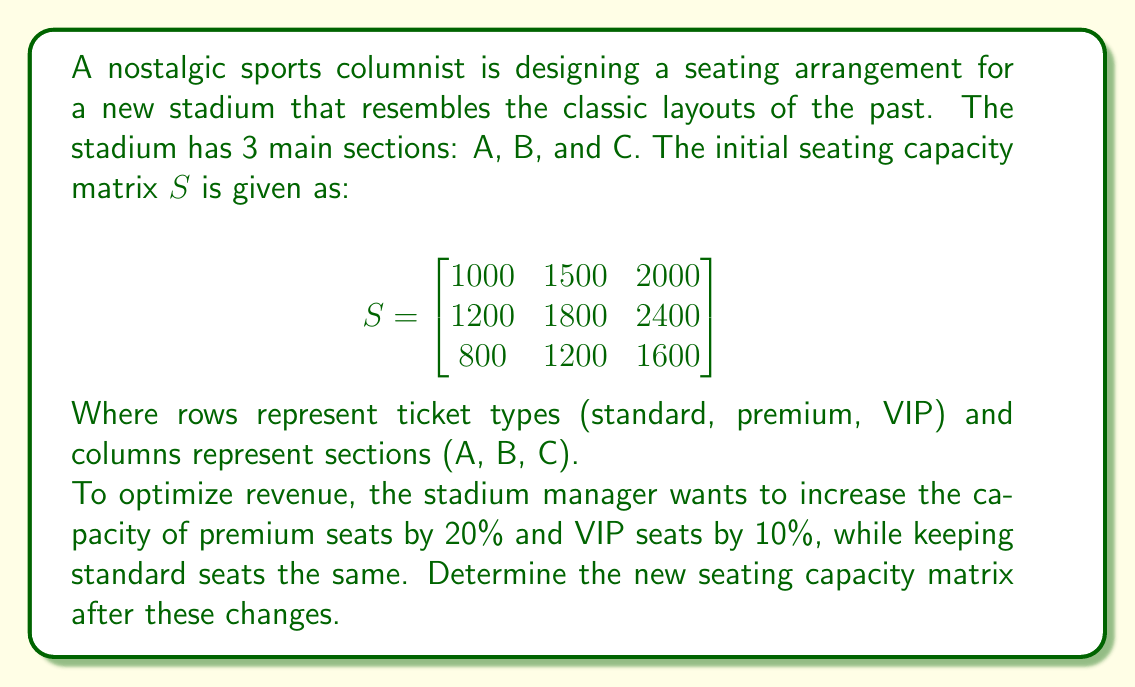Can you answer this question? Let's approach this step-by-step:

1) First, we need to create a scaling matrix $T$ that represents the changes in seating capacity:

   $$T = \begin{bmatrix}
   1 & 0 & 0 \\
   0 & 1.2 & 0 \\
   0 & 0 & 1.1
   \end{bmatrix}$$

   This matrix will keep standard seats the same (1), increase premium seats by 20% (1.2), and increase VIP seats by 10% (1.1).

2) To apply these changes, we need to multiply the scaling matrix $T$ by the original seating matrix $S$:

   $$T \cdot S = \begin{bmatrix}
   1 & 0 & 0 \\
   0 & 1.2 & 0 \\
   0 & 0 & 1.1
   \end{bmatrix} \cdot \begin{bmatrix}
   1000 & 1500 & 2000 \\
   1200 & 1800 & 2400 \\
   800 & 1200 & 1600
   \end{bmatrix}$$

3) Performing the matrix multiplication:

   $$\begin{bmatrix}
   1 \cdot 1000 & 1 \cdot 1500 & 1 \cdot 2000 \\
   1.2 \cdot 1200 & 1.2 \cdot 1800 & 1.2 \cdot 2400 \\
   1.1 \cdot 800 & 1.1 \cdot 1200 & 1.1 \cdot 1600
   \end{bmatrix}$$

4) Calculating the final values:

   $$\begin{bmatrix}
   1000 & 1500 & 2000 \\
   1440 & 2160 & 2880 \\
   880 & 1320 & 1760
   \end{bmatrix}$$

This is the new seating capacity matrix after the changes have been applied.
Answer: $$\begin{bmatrix}
1000 & 1500 & 2000 \\
1440 & 2160 & 2880 \\
880 & 1320 & 1760
\end{bmatrix}$$ 